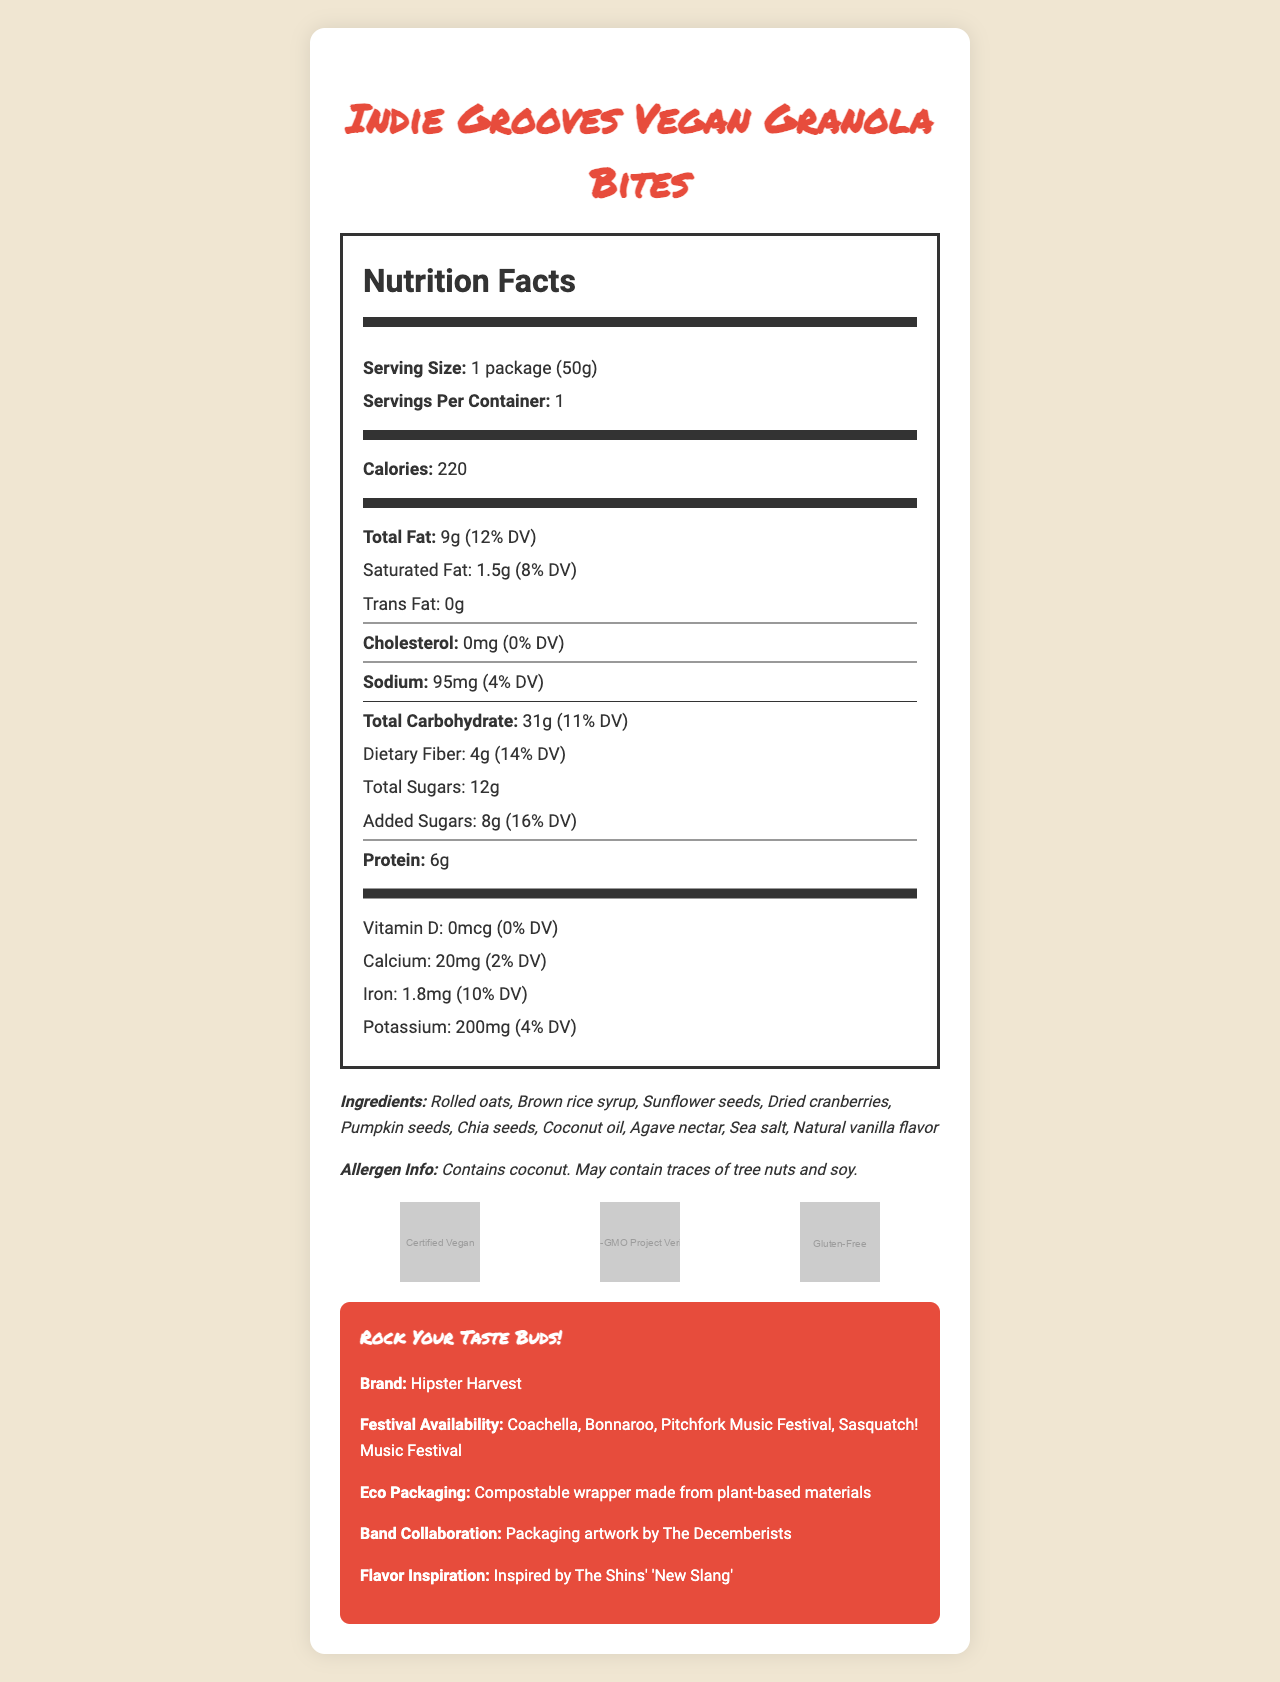what is the serving size of Indie Grooves Vegan Granola Bites? The document states that the serving size is 1 package, which weighs 50 grams.
Answer: 1 package (50g) how many calories are in one serving? The document lists the calories per serving as 220.
Answer: 220 what is the total fat content per serving? According to the document, the total fat content per serving is 9 grams.
Answer: 9g what are the main ingredients in Indie Grooves Vegan Granola Bites? The document specifies the main ingredients in the section labeled "Ingredients".
Answer: Rolled oats, Brown rice syrup, Sunflower seeds, Dried cranberries, Pumpkin seeds, Chia seeds, Coconut oil, Agave nectar, Sea salt, Natural vanilla flavor what is the daily value percentage for dietary fiber? The document mentions that the dietary fiber content provides 14% of the daily value.
Answer: 14% which of the following are certifications Indie Grooves Vegan Granola Bites have? A. USDA Organic B. Certified Vegan C. Fair Trade D. Gluten-Free The document shows images for certifications of "Certified Vegan" and "Gluten-Free".
Answer: B, D where are Indie Grooves Vegan Granola Bites available? A. Lollapalooza B. Coachella C. Bonnaroo D. Austin City Limits The document lists Coachella and Bonnaroo among the festivals where the product is available.
Answer: B, C does this product contain any cholesterol? The document specifies that the cholesterol amount is 0 mg, contributing 0% of the daily value.
Answer: No describe the main idea of the document The explanation is that the document comprehensively outlines the nutritional information, ingredients, certifications, and additional details about the product and its related features.
Answer: The document provides detailed nutrition facts, ingredients, allergen information, certifications, festival availability, eco-packaging details, and band collaboration for Indie Grooves Vegan Granola Bites. It highlights the vegan, non-GMO, and gluten-free attributes of the product, along with its availability at various music festivals. what is the amount of Vitamin D in the snack? The document lists the Vitamin D content as 0 mcg.
Answer: 0 mcg who designed the packaging artwork for the granola bites? The document mentions that the packaging artwork was done in collaboration with the band The Decemberists.
Answer: The Decemberists what is the flavor inspiration for Indie Grooves Vegan Granola Bites? The document states that the flavor inspiration comes from The Shins' song "New Slang".
Answer: Inspired by The Shins' "New Slang" what percentage of the daily value of calcium does one serving provide? The document shows that one serving provides 2% of the daily value for calcium.
Answer: 2% are the granola bites certified non-GMO? The document lists "Non-GMO Project Verified" among its certifications.
Answer: Yes what is the total carbohydrate amount in one serving? The document states that the total carbohydrate amount per serving is 31 grams.
Answer: 31g Which of the following festivals is NOT mentioned for festival availability? A. Coachella B. Lollapalooza C. Bonnaroo D. Pitchfork Music Festival The document does not list Lollapalooza in the festival availability section.
Answer: B what is the brand name of the Vegan Granola Bites? The additional info section states that the brand is Hipster Harvest.
Answer: Hipster Harvest does the product contain added sugars? According to the document, there are 8 grams of added sugars per serving.
Answer: Yes what is the purpose of the eco-packaging? The document mentions that the eco-packaging is a compostable wrapper made from plant-based materials.
Answer: Compostable wrapper made from plant-based materials what is the recommended daily intake value for potassium listed in the document? The document mentions the potassium content and daily value percentage, but does not provide the recommended daily intake value.
Answer: Cannot be determined 